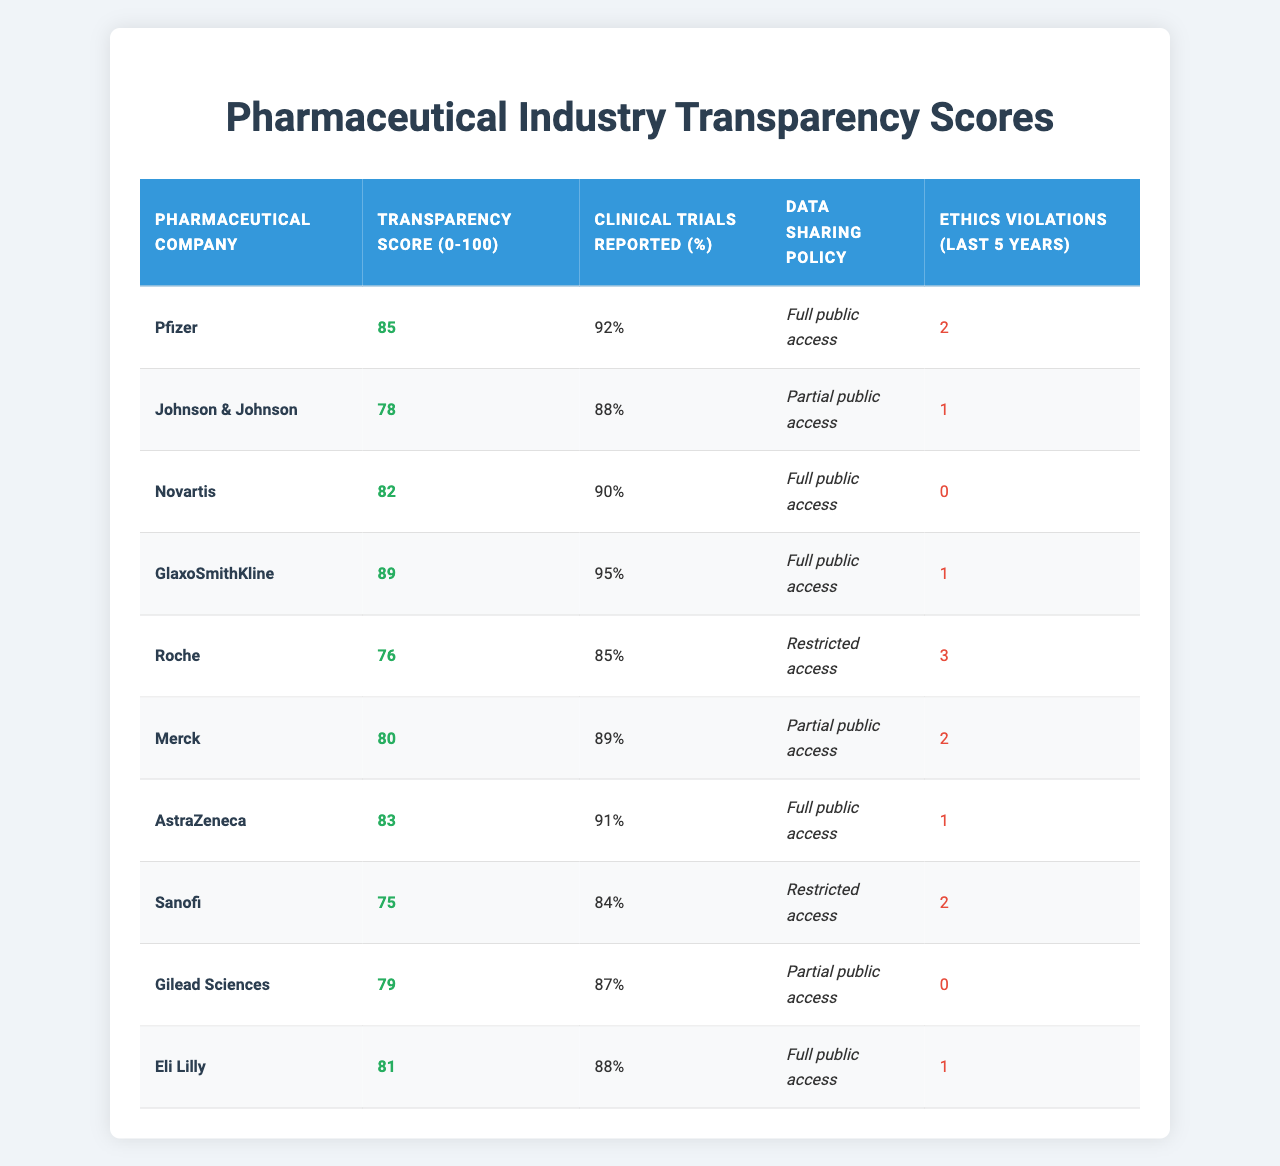What is the Transparency Score of GlaxoSmithKline? GlaxoSmithKline's Transparency Score is clearly shown in the table under the respective column, which is 89.
Answer: 89 Which company has the highest Clinical Trials Reported percentage? By comparing the values in the Clinical Trials Reported column, GlaxoSmithKline has the highest percentage at 95%.
Answer: 95% How many companies have a Data Sharing Policy of "Full public access"? The table shows several companies with a "Full public access" policy: Pfizer, Novartis, GlaxoSmithKline, AstraZeneca, and Eli Lilly. Counting these gives a total of 5 companies.
Answer: 5 What is the average Transparency Score of companies with Restricted access data sharing policies? The companies with "Restricted access" are Roche and Sanofi. Their scores are 76 and 75, respectively. The average score is (76 + 75) / 2 = 75.5.
Answer: 75.5 Are there any companies with zero ethics violations in the last five years? Looking at the Ethics Violations column, Novartis and Gilead Sciences both have 0 violations, indicating there are companies without any reported violations.
Answer: Yes What is the difference in Transparency Scores between the highest and the lowest scoring companies? The highest Transparency Score, 89 (GlaxoSmithKline), and the lowest score, 75 (Sanofi), results in a difference of 89 - 75 = 14.
Answer: 14 Which company has both a high Transparency Score and no Ethics Violations? By reviewing the Transparency Score and Ethics Violations columns, we see that Novartis has a score of 82 and zero ethics violations, fulfilling both conditions.
Answer: Novartis How many companies reported more than 90% of their clinical trials? The Clinical Trials Reported values of Pfizer, Novartis, GlaxoSmithKline, and AstraZeneca are compared, and all are above 90%, resulting in 4 companies that meet this criterion.
Answer: 4 What is the total number of ethics violations reported by companies with "Partial public access"? The companies with "Partial public access" are Johnson & Johnson, Merck, and Gilead Sciences, with violations of 1, 2, and 0, respectively. Adding these gives 1 + 2 + 0 = 3 total violations.
Answer: 3 Which company has the least transparency score among the listed companies? The least transparency score in the table is 75, which belongs to Sanofi when comparing all the scores listed.
Answer: Sanofi 